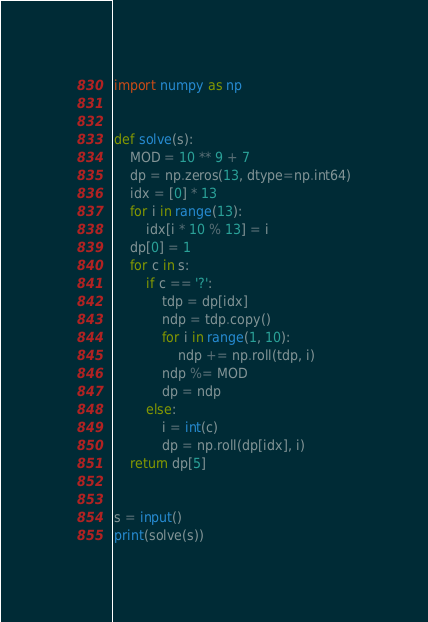<code> <loc_0><loc_0><loc_500><loc_500><_Python_>import numpy as np


def solve(s):
    MOD = 10 ** 9 + 7
    dp = np.zeros(13, dtype=np.int64)
    idx = [0] * 13
    for i in range(13):
        idx[i * 10 % 13] = i
    dp[0] = 1
    for c in s:
        if c == '?':
            tdp = dp[idx]
            ndp = tdp.copy()
            for i in range(1, 10):
                ndp += np.roll(tdp, i)
            ndp %= MOD
            dp = ndp
        else:
            i = int(c)
            dp = np.roll(dp[idx], i)
    return dp[5]


s = input()
print(solve(s))
</code> 